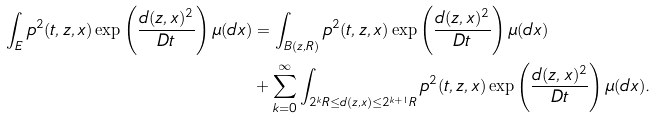<formula> <loc_0><loc_0><loc_500><loc_500>\int _ { E } p ^ { 2 } ( t , z , x ) \exp \left ( \frac { d ( z , x ) ^ { 2 } } { D t } \right ) \mu ( d x ) & = \int _ { B ( z , R ) } p ^ { 2 } ( t , z , x ) \exp \left ( \frac { d ( z , x ) ^ { 2 } } { D t } \right ) \mu ( d x ) \\ & + \sum _ { k = 0 } ^ { \infty } \int _ { 2 ^ { k } R \leq d ( z , x ) \leq 2 ^ { k + 1 } R } p ^ { 2 } ( t , z , x ) \exp \left ( \frac { d ( z , x ) ^ { 2 } } { D t } \right ) \mu ( d x ) .</formula> 